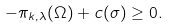Convert formula to latex. <formula><loc_0><loc_0><loc_500><loc_500>- \pi _ { k , \lambda } ( \Omega ) + c ( \sigma ) \geq 0 .</formula> 